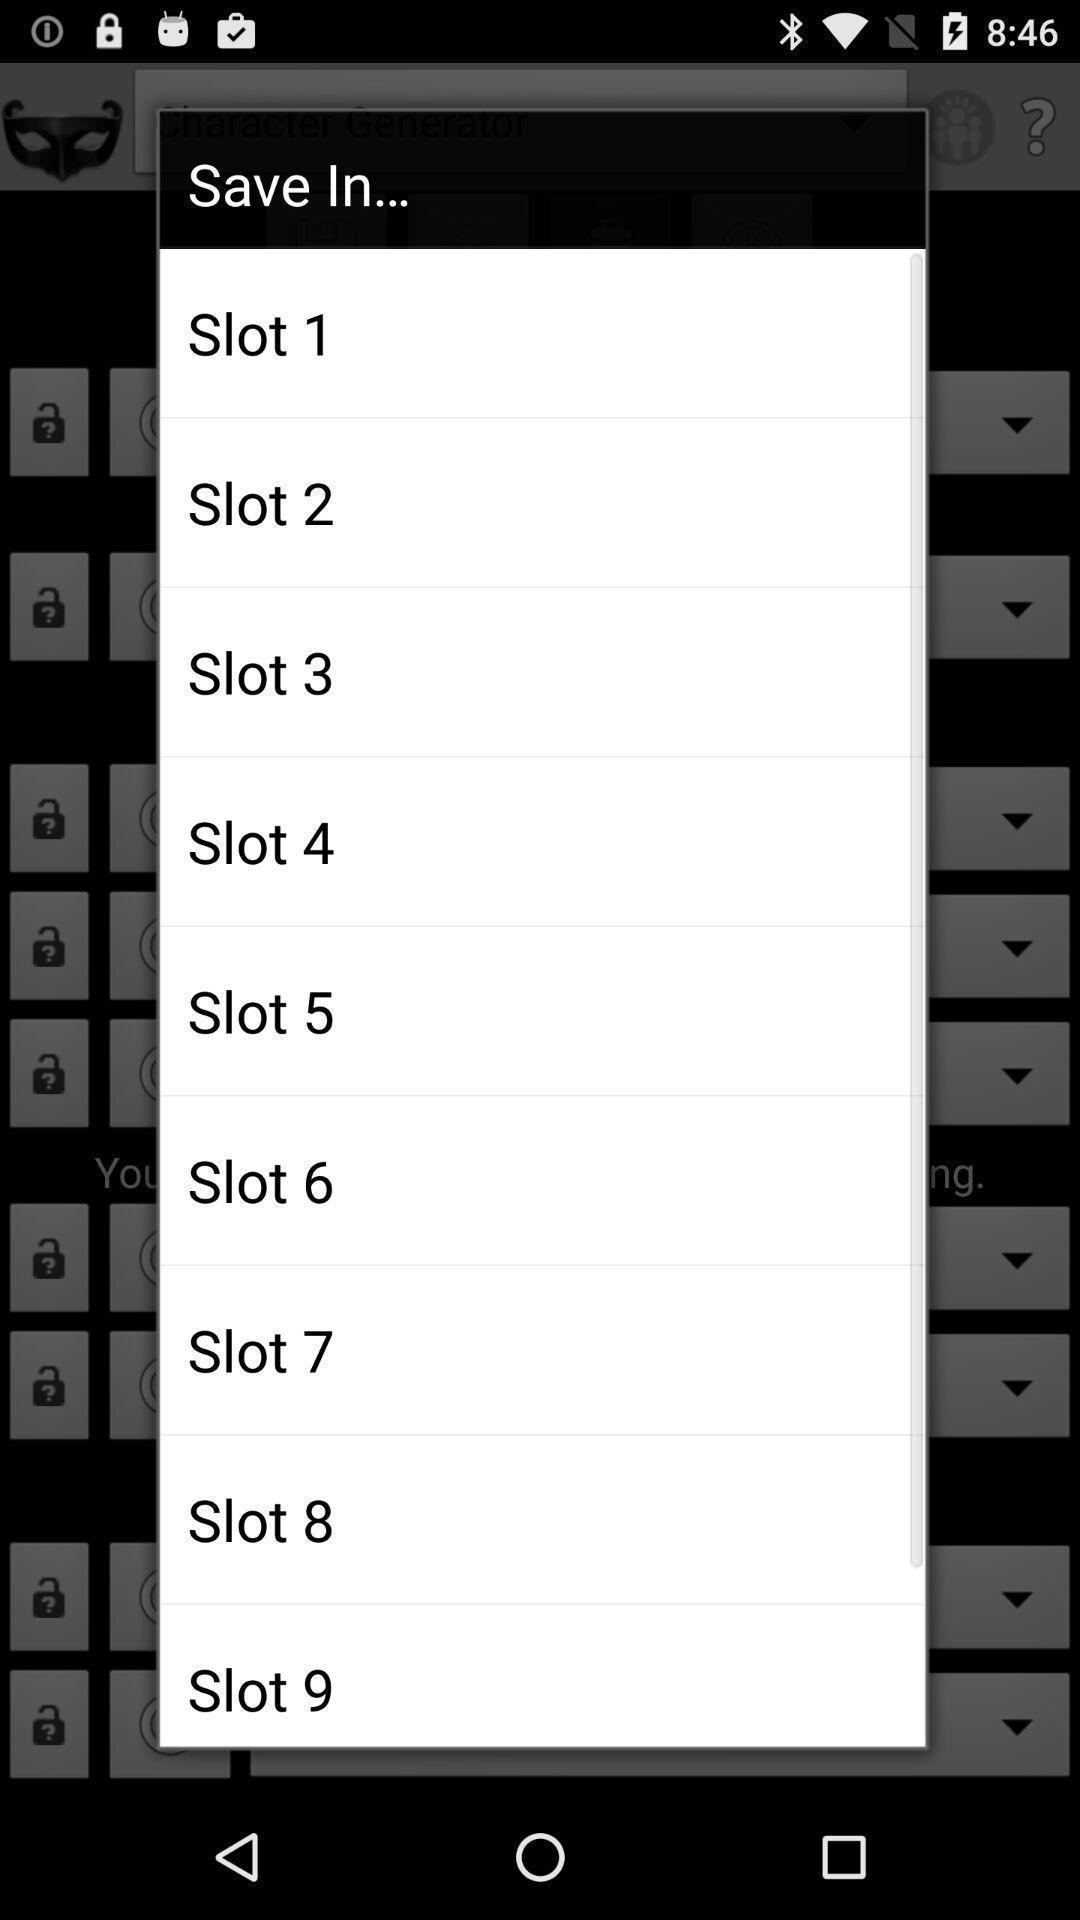Provide a detailed account of this screenshot. Screen displaying list of options to save. 